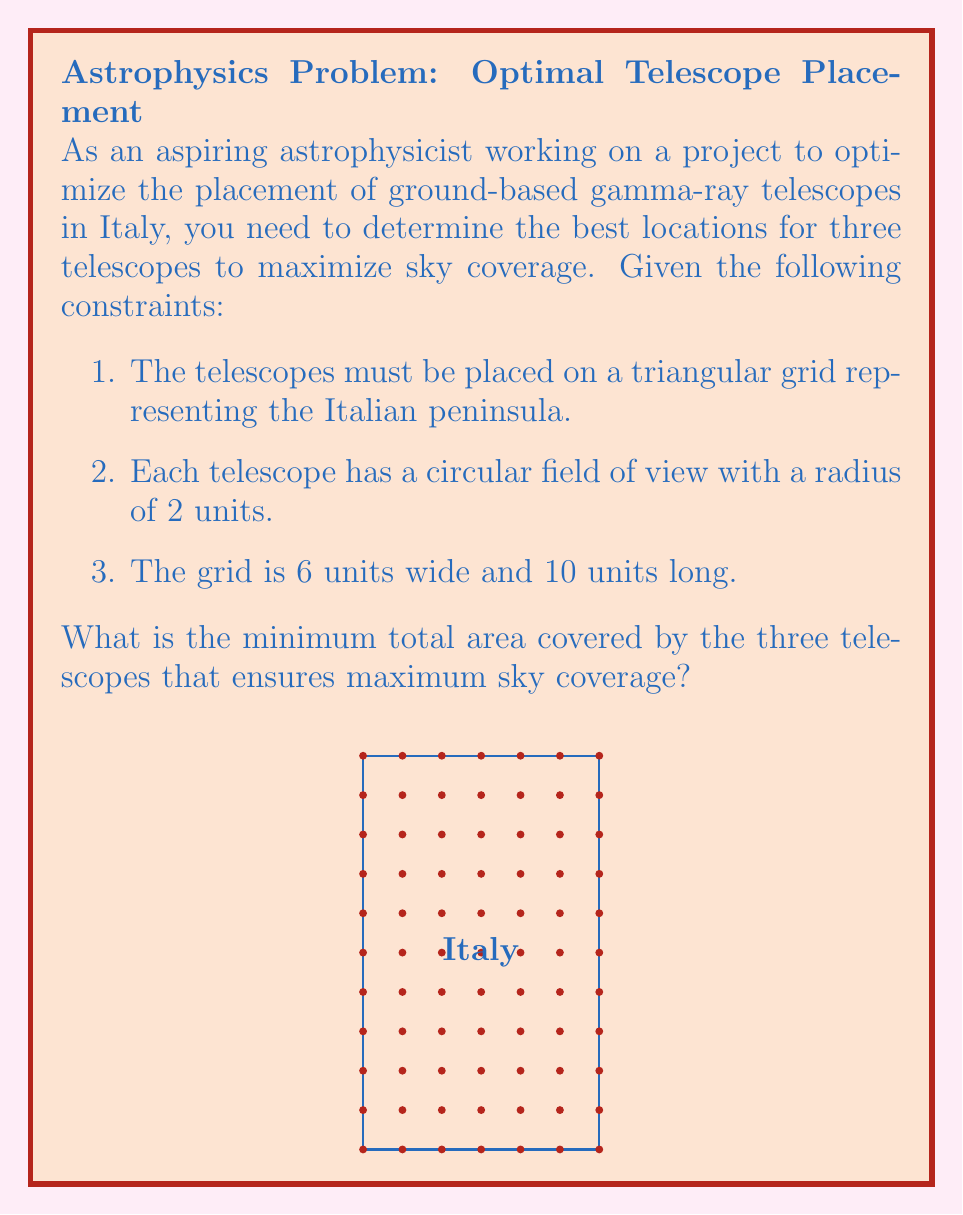Provide a solution to this math problem. To solve this problem, we'll follow these steps:

1) First, we need to understand that to maximize sky coverage, we should minimize overlap between the telescopes' fields of view while covering as much of the grid as possible.

2) The optimal placement would be to form an equilateral triangle with the telescopes at the vertices. This arrangement minimizes overlap while maximizing coverage.

3) Given that the grid is 6 units wide and 10 units long, we can place the telescopes at the following coordinates:
   Telescope 1: (1, 2)
   Telescope 2: (5, 2)
   Telescope 3: (3, 6)

4) Now, we need to calculate the area covered by these three telescopes. The area of a single telescope's field of view is:

   $$A = \pi r^2 = \pi (2^2) = 4\pi$$

5) However, there will be some overlap between the fields of view. To calculate the total area, we need to use the formula for the area of the union of three circles:

   $$A_{total} = 3A - A_{12} - A_{23} - A_{13} + A_{123}$$

   Where $A$ is the area of one circle, $A_{ij}$ is the area of intersection between two circles, and $A_{123}$ is the area of intersection between all three circles.

6) The area of intersection between two circles can be calculated using the formula:

   $$A_{int} = 2r^2 \arccos(\frac{d}{2r}) - d\sqrt{r^2 - (\frac{d}{2})^2}$$

   Where $r$ is the radius (2 in this case) and $d$ is the distance between the centers of the circles (4 in this case).

7) Calculating:
   $$A_{int} = 2(2^2) \arccos(\frac{4}{2(2)}) - 4\sqrt{2^2 - (\frac{4}{2})^2} \approx 1.2284$$

8) The area of intersection between all three circles ($A_{123}$) is negligible in this case due to the placement of the telescopes.

9) Therefore, the total area covered is:

   $$A_{total} = 3(4\pi) - 3(1.2284) \approx 34.2860$$
Answer: $34.2860$ square units 